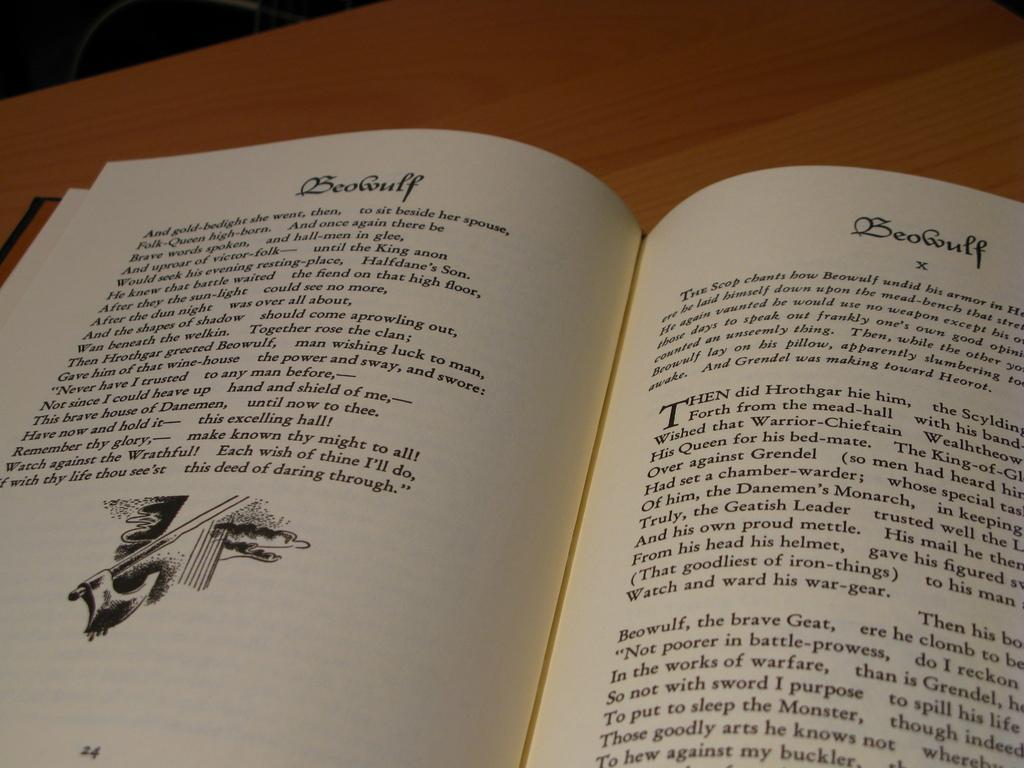What is the title of the story?
Your response must be concise. Beowulf. 